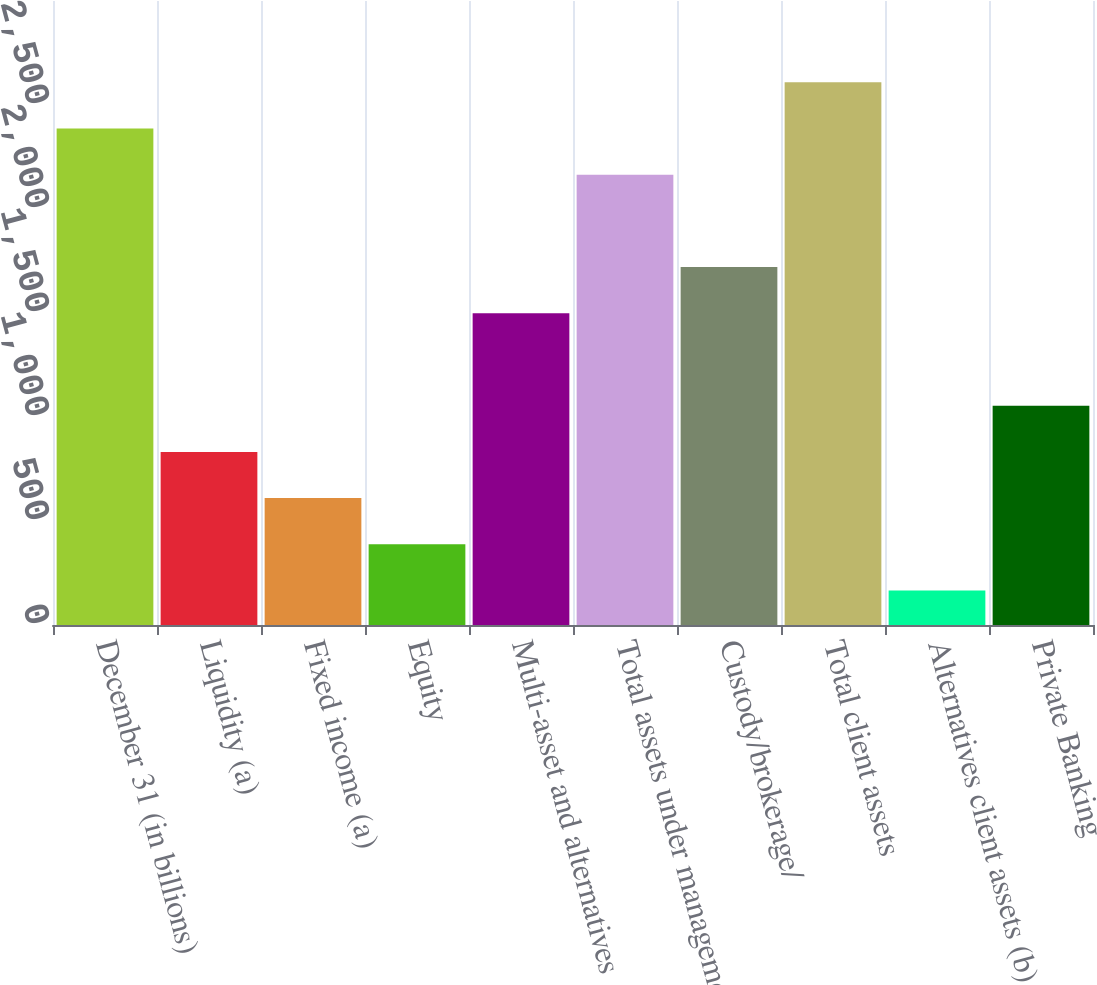Convert chart. <chart><loc_0><loc_0><loc_500><loc_500><bar_chart><fcel>December 31 (in billions)<fcel>Liquidity (a)<fcel>Fixed income (a)<fcel>Equity<fcel>Multi-asset and alternatives<fcel>Total assets under management<fcel>Custody/brokerage/<fcel>Total client assets<fcel>Alternatives client assets (b)<fcel>Private Banking<nl><fcel>2387<fcel>832.3<fcel>610.2<fcel>388.1<fcel>1498.6<fcel>2164.9<fcel>1720.7<fcel>2609.1<fcel>166<fcel>1054.4<nl></chart> 